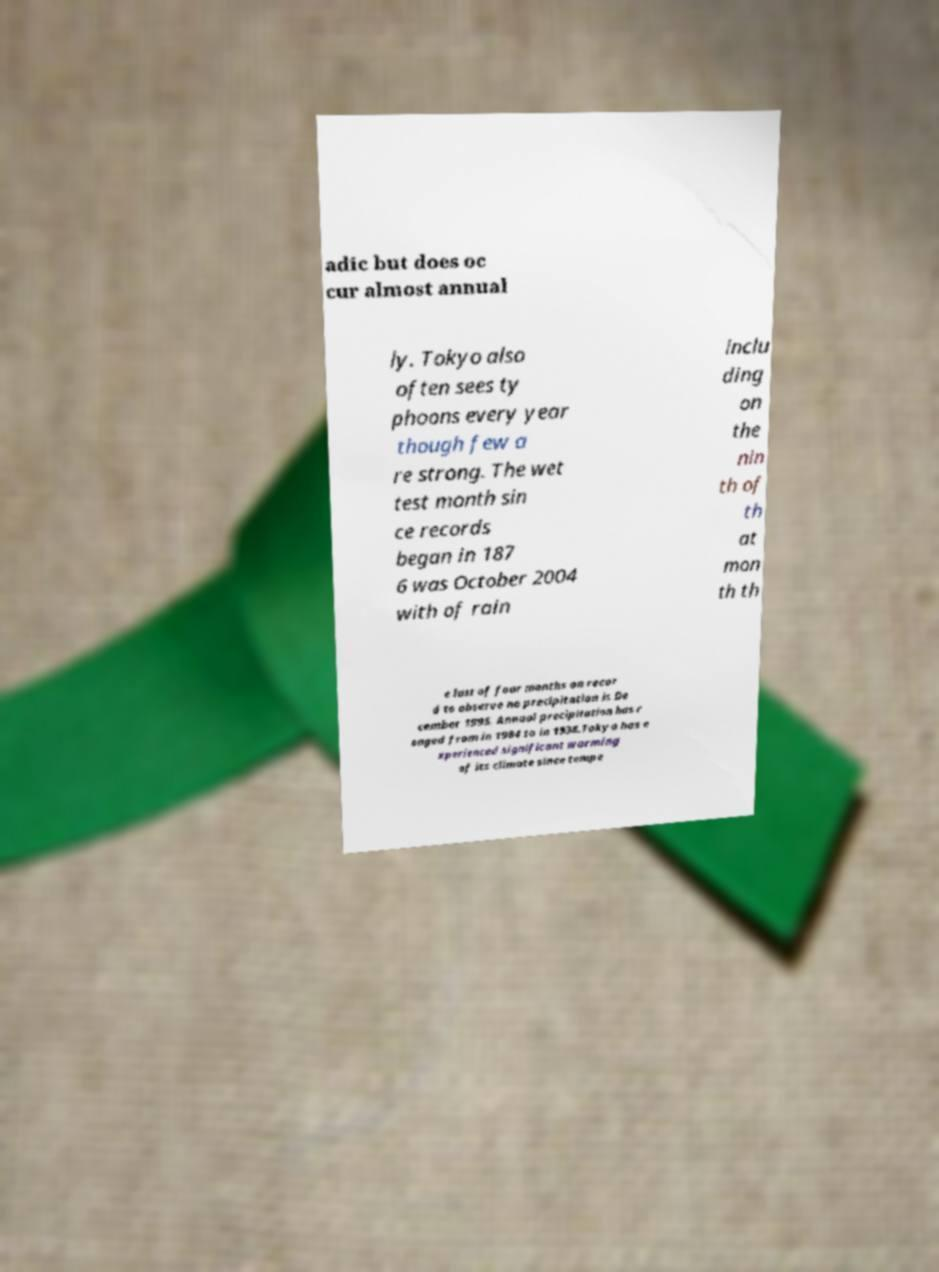Can you accurately transcribe the text from the provided image for me? adic but does oc cur almost annual ly. Tokyo also often sees ty phoons every year though few a re strong. The wet test month sin ce records began in 187 6 was October 2004 with of rain inclu ding on the nin th of th at mon th th e last of four months on recor d to observe no precipitation is De cember 1995. Annual precipitation has r anged from in 1984 to in 1938.Tokyo has e xperienced significant warming of its climate since tempe 